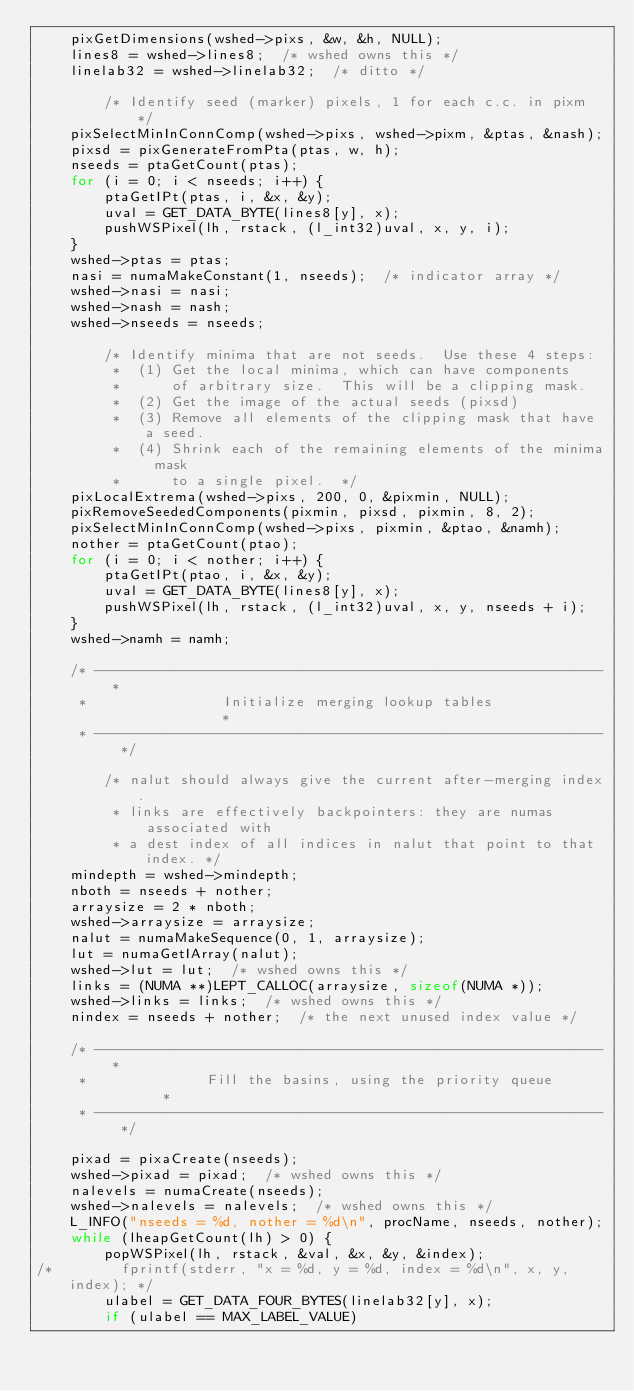<code> <loc_0><loc_0><loc_500><loc_500><_C_>    pixGetDimensions(wshed->pixs, &w, &h, NULL);
    lines8 = wshed->lines8;  /* wshed owns this */
    linelab32 = wshed->linelab32;  /* ditto */

        /* Identify seed (marker) pixels, 1 for each c.c. in pixm */
    pixSelectMinInConnComp(wshed->pixs, wshed->pixm, &ptas, &nash);
    pixsd = pixGenerateFromPta(ptas, w, h);
    nseeds = ptaGetCount(ptas);
    for (i = 0; i < nseeds; i++) {
        ptaGetIPt(ptas, i, &x, &y);
        uval = GET_DATA_BYTE(lines8[y], x);
        pushWSPixel(lh, rstack, (l_int32)uval, x, y, i);
    }
    wshed->ptas = ptas;
    nasi = numaMakeConstant(1, nseeds);  /* indicator array */
    wshed->nasi = nasi;
    wshed->nash = nash;
    wshed->nseeds = nseeds;

        /* Identify minima that are not seeds.  Use these 4 steps:
         *  (1) Get the local minima, which can have components
         *      of arbitrary size.  This will be a clipping mask.
         *  (2) Get the image of the actual seeds (pixsd)
         *  (3) Remove all elements of the clipping mask that have a seed.
         *  (4) Shrink each of the remaining elements of the minima mask
         *      to a single pixel.  */
    pixLocalExtrema(wshed->pixs, 200, 0, &pixmin, NULL);
    pixRemoveSeededComponents(pixmin, pixsd, pixmin, 8, 2);
    pixSelectMinInConnComp(wshed->pixs, pixmin, &ptao, &namh);
    nother = ptaGetCount(ptao);
    for (i = 0; i < nother; i++) {
        ptaGetIPt(ptao, i, &x, &y);
        uval = GET_DATA_BYTE(lines8[y], x);
        pushWSPixel(lh, rstack, (l_int32)uval, x, y, nseeds + i);
    }
    wshed->namh = namh;

    /* ------------------------------------------------------------ *
     *                Initialize merging lookup tables              *
     * ------------------------------------------------------------ */

        /* nalut should always give the current after-merging index.
         * links are effectively backpointers: they are numas associated with
         * a dest index of all indices in nalut that point to that index. */
    mindepth = wshed->mindepth;
    nboth = nseeds + nother;
    arraysize = 2 * nboth;
    wshed->arraysize = arraysize;
    nalut = numaMakeSequence(0, 1, arraysize);
    lut = numaGetIArray(nalut);
    wshed->lut = lut;  /* wshed owns this */
    links = (NUMA **)LEPT_CALLOC(arraysize, sizeof(NUMA *));
    wshed->links = links;  /* wshed owns this */
    nindex = nseeds + nother;  /* the next unused index value */

    /* ------------------------------------------------------------ *
     *              Fill the basins, using the priority queue       *
     * ------------------------------------------------------------ */

    pixad = pixaCreate(nseeds);
    wshed->pixad = pixad;  /* wshed owns this */
    nalevels = numaCreate(nseeds);
    wshed->nalevels = nalevels;  /* wshed owns this */
    L_INFO("nseeds = %d, nother = %d\n", procName, nseeds, nother);
    while (lheapGetCount(lh) > 0) {
        popWSPixel(lh, rstack, &val, &x, &y, &index);
/*        fprintf(stderr, "x = %d, y = %d, index = %d\n", x, y, index); */
        ulabel = GET_DATA_FOUR_BYTES(linelab32[y], x);
        if (ulabel == MAX_LABEL_VALUE)</code> 